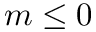<formula> <loc_0><loc_0><loc_500><loc_500>m \leq 0</formula> 